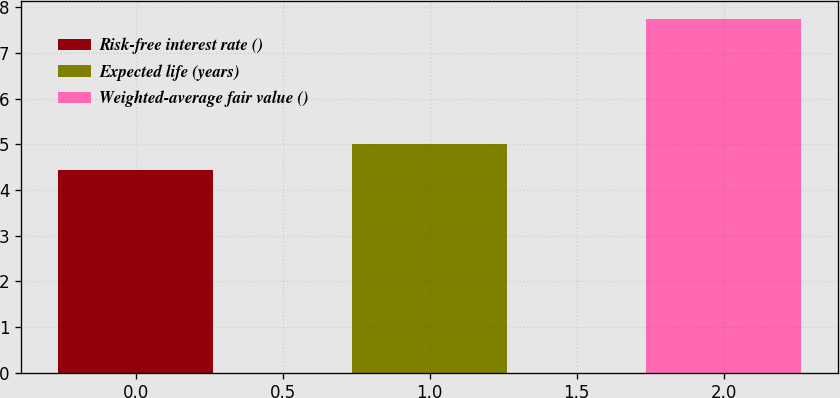Convert chart to OTSL. <chart><loc_0><loc_0><loc_500><loc_500><bar_chart><fcel>Risk-free interest rate ()<fcel>Expected life (years)<fcel>Weighted-average fair value ()<nl><fcel>4.45<fcel>5<fcel>7.75<nl></chart> 